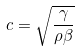<formula> <loc_0><loc_0><loc_500><loc_500>c = \sqrt { \frac { \gamma } { \rho \beta } }</formula> 